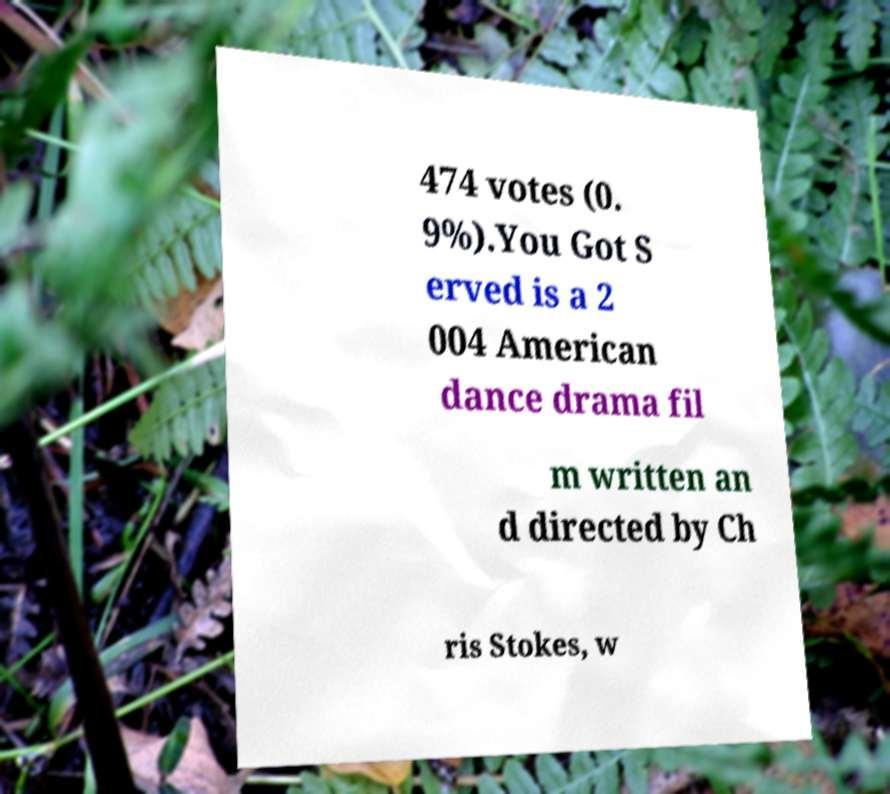For documentation purposes, I need the text within this image transcribed. Could you provide that? 474 votes (0. 9%).You Got S erved is a 2 004 American dance drama fil m written an d directed by Ch ris Stokes, w 